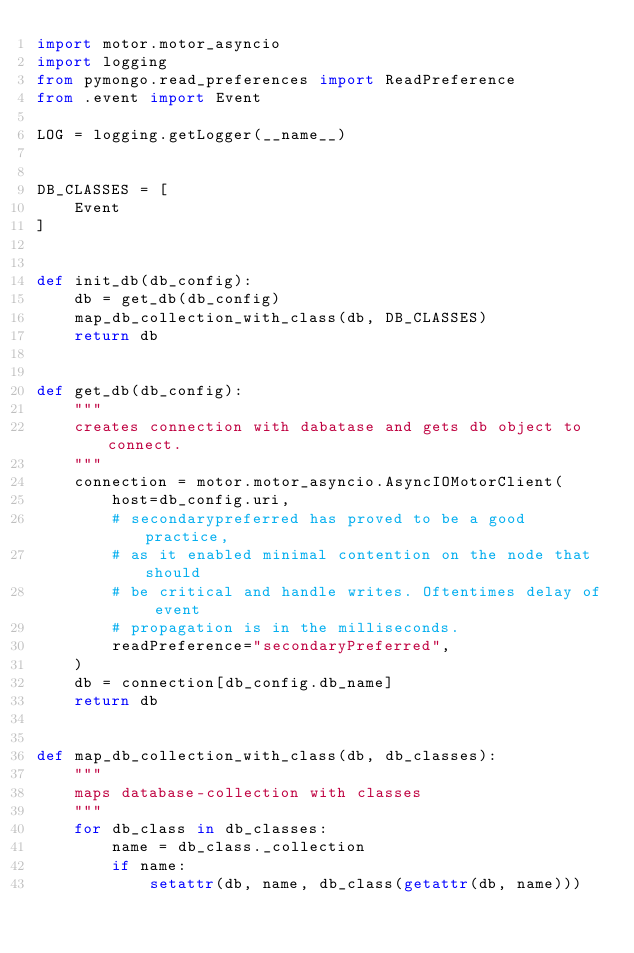Convert code to text. <code><loc_0><loc_0><loc_500><loc_500><_Python_>import motor.motor_asyncio
import logging
from pymongo.read_preferences import ReadPreference
from .event import Event

LOG = logging.getLogger(__name__)


DB_CLASSES = [
    Event
]


def init_db(db_config):
    db = get_db(db_config)
    map_db_collection_with_class(db, DB_CLASSES)
    return db


def get_db(db_config):
    """
    creates connection with dabatase and gets db object to connect.
    """
    connection = motor.motor_asyncio.AsyncIOMotorClient(
        host=db_config.uri,
        # secondarypreferred has proved to be a good practice,
        # as it enabled minimal contention on the node that should
        # be critical and handle writes. Oftentimes delay of event
        # propagation is in the milliseconds.
        readPreference="secondaryPreferred",
    )
    db = connection[db_config.db_name]
    return db


def map_db_collection_with_class(db, db_classes):
    """
    maps database-collection with classes
    """
    for db_class in db_classes:
        name = db_class._collection
        if name:
            setattr(db, name, db_class(getattr(db, name)))
</code> 